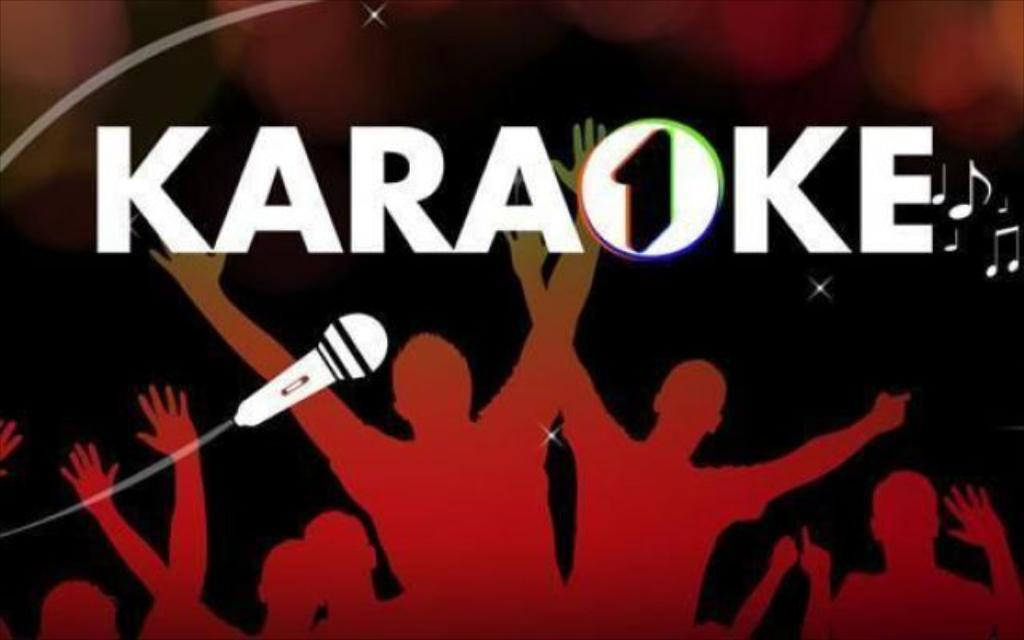<image>
Give a short and clear explanation of the subsequent image. A poster with the outlines of people cheering and the word Karaoke 